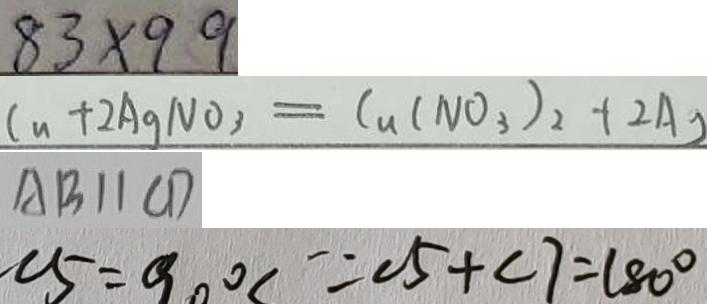<formula> <loc_0><loc_0><loc_500><loc_500>8 3 \times 9 9 
 C u + 2 A g N O _ { 3 } = C u ( N O _ { 3 } ) _ { 2 } + 2 A g 
 A B / / C D 
 \angle 5 = 9 0 ^ { \circ } \because \angle 5 + \angle 7 = 1 8 0 ^ { \circ }</formula> 